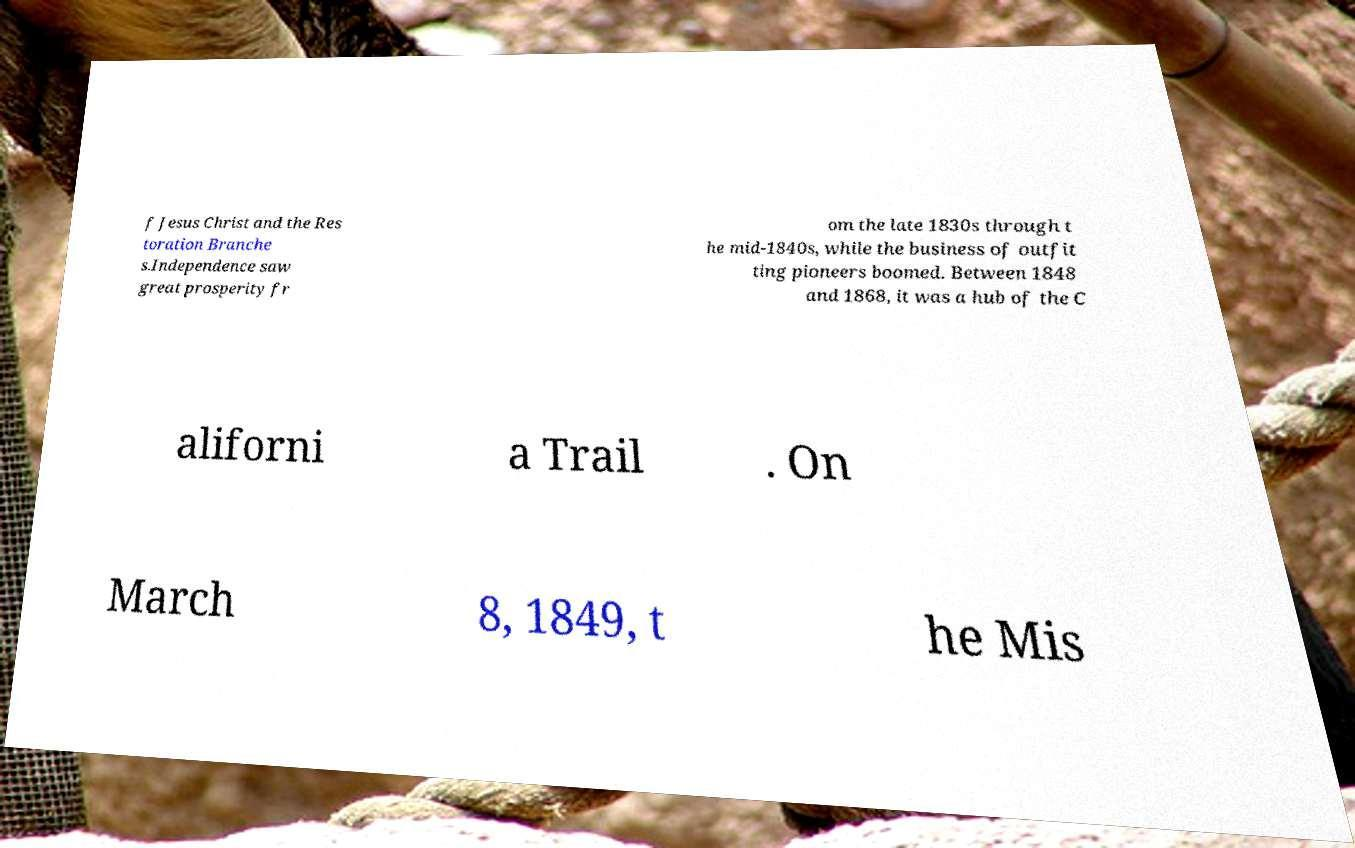I need the written content from this picture converted into text. Can you do that? f Jesus Christ and the Res toration Branche s.Independence saw great prosperity fr om the late 1830s through t he mid-1840s, while the business of outfit ting pioneers boomed. Between 1848 and 1868, it was a hub of the C aliforni a Trail . On March 8, 1849, t he Mis 